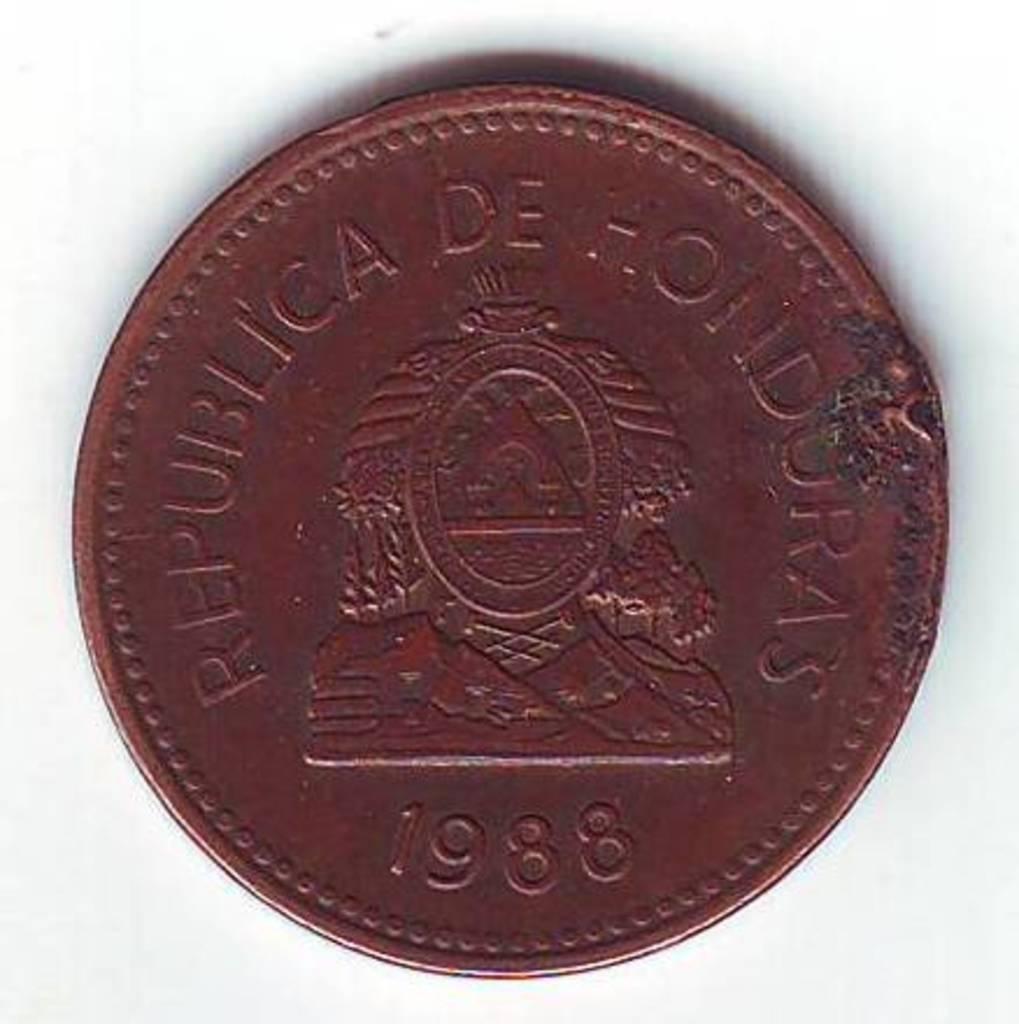Is this a real coin to use?
Provide a short and direct response. Yes. What year was this made in?
Offer a terse response. 1988. 